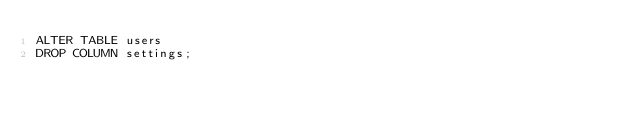<code> <loc_0><loc_0><loc_500><loc_500><_SQL_>ALTER TABLE users
DROP COLUMN settings;
</code> 